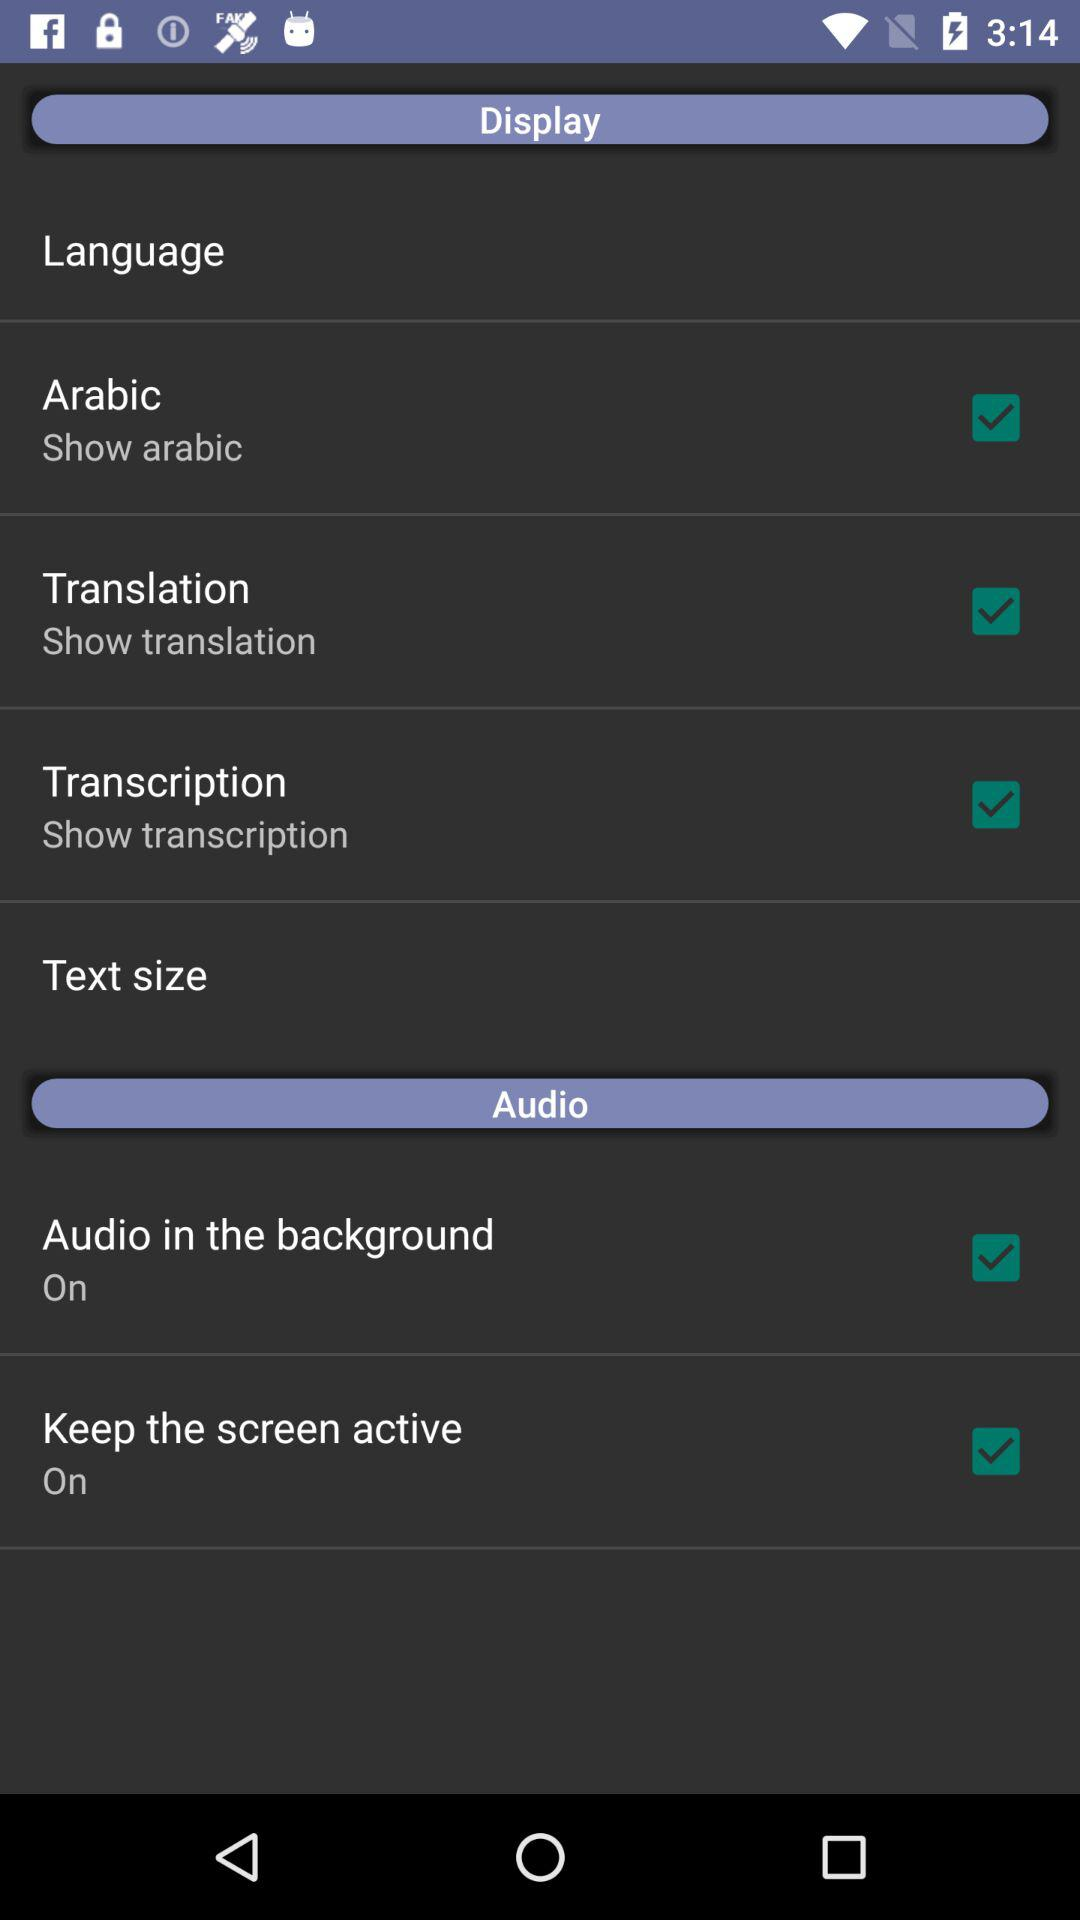What language is opted to be displayed on the display? The language is Arabic. 